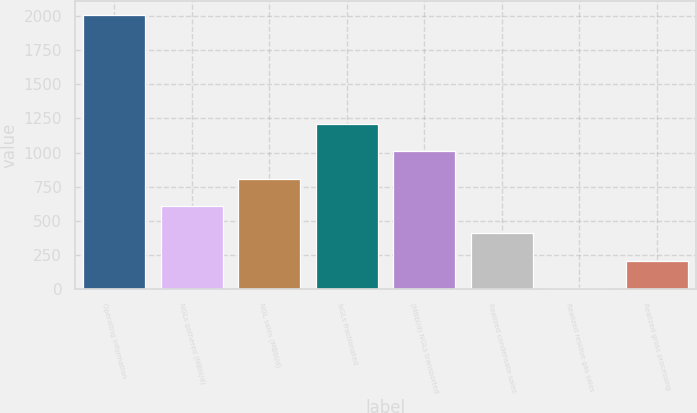Convert chart to OTSL. <chart><loc_0><loc_0><loc_500><loc_500><bar_chart><fcel>Operating Information<fcel>NGLs gathered (MBbl/d)<fcel>NGL sales (MBbl/d)<fcel>NGLs fractionated<fcel>(MBbl/d) NGLs transported<fcel>Realized condensate sales<fcel>Realized residue gas sales<fcel>Realized gross processing<nl><fcel>2008<fcel>607.55<fcel>807.62<fcel>1207.76<fcel>1007.69<fcel>407.48<fcel>7.34<fcel>207.41<nl></chart> 